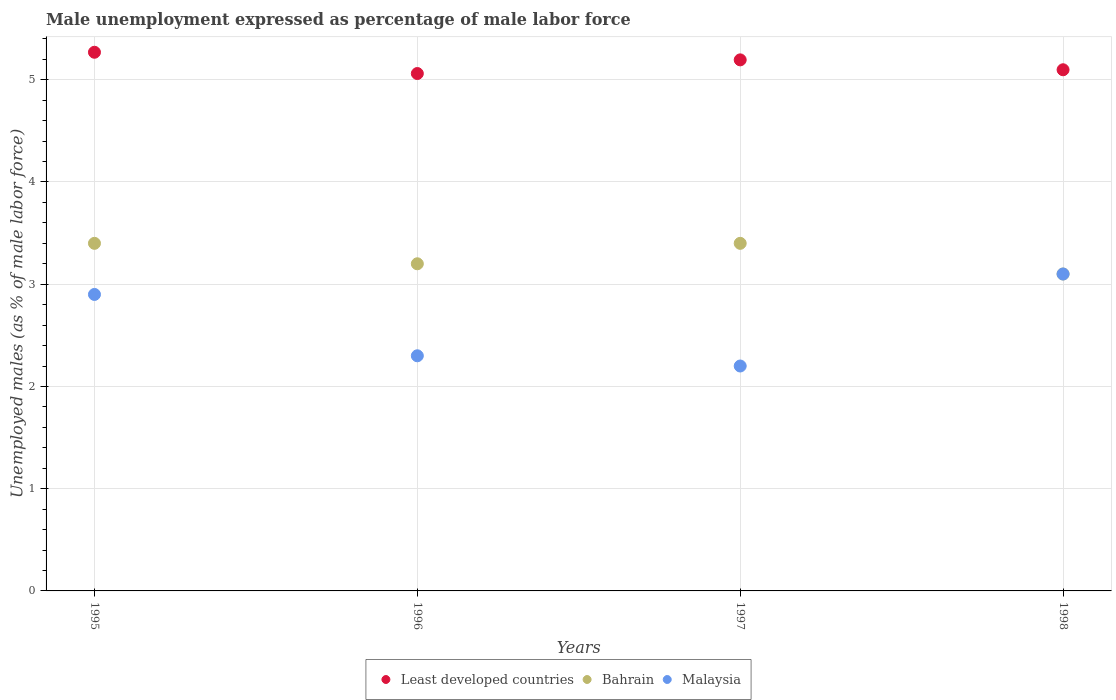How many different coloured dotlines are there?
Give a very brief answer. 3. What is the unemployment in males in in Malaysia in 1995?
Provide a succinct answer. 2.9. Across all years, what is the maximum unemployment in males in in Bahrain?
Provide a succinct answer. 3.4. Across all years, what is the minimum unemployment in males in in Bahrain?
Provide a short and direct response. 3.1. In which year was the unemployment in males in in Least developed countries minimum?
Offer a very short reply. 1996. What is the total unemployment in males in in Malaysia in the graph?
Ensure brevity in your answer.  10.5. What is the difference between the unemployment in males in in Bahrain in 1997 and that in 1998?
Provide a succinct answer. 0.3. What is the difference between the unemployment in males in in Bahrain in 1995 and the unemployment in males in in Least developed countries in 1996?
Offer a terse response. -1.66. What is the average unemployment in males in in Bahrain per year?
Make the answer very short. 3.28. In the year 1996, what is the difference between the unemployment in males in in Least developed countries and unemployment in males in in Malaysia?
Offer a very short reply. 2.76. What is the ratio of the unemployment in males in in Least developed countries in 1995 to that in 1997?
Provide a short and direct response. 1.01. Is the difference between the unemployment in males in in Least developed countries in 1995 and 1998 greater than the difference between the unemployment in males in in Malaysia in 1995 and 1998?
Provide a succinct answer. Yes. What is the difference between the highest and the lowest unemployment in males in in Least developed countries?
Your answer should be compact. 0.21. In how many years, is the unemployment in males in in Least developed countries greater than the average unemployment in males in in Least developed countries taken over all years?
Your answer should be very brief. 2. Is it the case that in every year, the sum of the unemployment in males in in Least developed countries and unemployment in males in in Bahrain  is greater than the unemployment in males in in Malaysia?
Give a very brief answer. Yes. Does the unemployment in males in in Malaysia monotonically increase over the years?
Your answer should be compact. No. Is the unemployment in males in in Malaysia strictly greater than the unemployment in males in in Least developed countries over the years?
Give a very brief answer. No. What is the difference between two consecutive major ticks on the Y-axis?
Keep it short and to the point. 1. Does the graph contain any zero values?
Keep it short and to the point. No. Does the graph contain grids?
Keep it short and to the point. Yes. Where does the legend appear in the graph?
Give a very brief answer. Bottom center. How many legend labels are there?
Provide a succinct answer. 3. How are the legend labels stacked?
Your answer should be very brief. Horizontal. What is the title of the graph?
Your answer should be compact. Male unemployment expressed as percentage of male labor force. Does "Jordan" appear as one of the legend labels in the graph?
Make the answer very short. No. What is the label or title of the X-axis?
Your response must be concise. Years. What is the label or title of the Y-axis?
Make the answer very short. Unemployed males (as % of male labor force). What is the Unemployed males (as % of male labor force) of Least developed countries in 1995?
Make the answer very short. 5.27. What is the Unemployed males (as % of male labor force) of Bahrain in 1995?
Give a very brief answer. 3.4. What is the Unemployed males (as % of male labor force) of Malaysia in 1995?
Offer a terse response. 2.9. What is the Unemployed males (as % of male labor force) of Least developed countries in 1996?
Offer a very short reply. 5.06. What is the Unemployed males (as % of male labor force) in Bahrain in 1996?
Make the answer very short. 3.2. What is the Unemployed males (as % of male labor force) of Malaysia in 1996?
Your answer should be very brief. 2.3. What is the Unemployed males (as % of male labor force) of Least developed countries in 1997?
Give a very brief answer. 5.19. What is the Unemployed males (as % of male labor force) of Bahrain in 1997?
Provide a succinct answer. 3.4. What is the Unemployed males (as % of male labor force) in Malaysia in 1997?
Provide a short and direct response. 2.2. What is the Unemployed males (as % of male labor force) of Least developed countries in 1998?
Offer a terse response. 5.1. What is the Unemployed males (as % of male labor force) in Bahrain in 1998?
Provide a short and direct response. 3.1. What is the Unemployed males (as % of male labor force) in Malaysia in 1998?
Offer a terse response. 3.1. Across all years, what is the maximum Unemployed males (as % of male labor force) in Least developed countries?
Your answer should be compact. 5.27. Across all years, what is the maximum Unemployed males (as % of male labor force) in Bahrain?
Provide a succinct answer. 3.4. Across all years, what is the maximum Unemployed males (as % of male labor force) of Malaysia?
Your answer should be compact. 3.1. Across all years, what is the minimum Unemployed males (as % of male labor force) of Least developed countries?
Offer a terse response. 5.06. Across all years, what is the minimum Unemployed males (as % of male labor force) of Bahrain?
Offer a very short reply. 3.1. Across all years, what is the minimum Unemployed males (as % of male labor force) in Malaysia?
Provide a succinct answer. 2.2. What is the total Unemployed males (as % of male labor force) of Least developed countries in the graph?
Offer a very short reply. 20.62. What is the total Unemployed males (as % of male labor force) in Bahrain in the graph?
Your answer should be very brief. 13.1. What is the total Unemployed males (as % of male labor force) of Malaysia in the graph?
Your response must be concise. 10.5. What is the difference between the Unemployed males (as % of male labor force) in Least developed countries in 1995 and that in 1996?
Your answer should be very brief. 0.21. What is the difference between the Unemployed males (as % of male labor force) of Malaysia in 1995 and that in 1996?
Offer a terse response. 0.6. What is the difference between the Unemployed males (as % of male labor force) of Least developed countries in 1995 and that in 1997?
Make the answer very short. 0.07. What is the difference between the Unemployed males (as % of male labor force) in Malaysia in 1995 and that in 1997?
Your response must be concise. 0.7. What is the difference between the Unemployed males (as % of male labor force) in Least developed countries in 1995 and that in 1998?
Offer a very short reply. 0.17. What is the difference between the Unemployed males (as % of male labor force) in Bahrain in 1995 and that in 1998?
Your answer should be very brief. 0.3. What is the difference between the Unemployed males (as % of male labor force) in Malaysia in 1995 and that in 1998?
Provide a short and direct response. -0.2. What is the difference between the Unemployed males (as % of male labor force) in Least developed countries in 1996 and that in 1997?
Provide a succinct answer. -0.13. What is the difference between the Unemployed males (as % of male labor force) of Bahrain in 1996 and that in 1997?
Your response must be concise. -0.2. What is the difference between the Unemployed males (as % of male labor force) of Malaysia in 1996 and that in 1997?
Your response must be concise. 0.1. What is the difference between the Unemployed males (as % of male labor force) in Least developed countries in 1996 and that in 1998?
Keep it short and to the point. -0.04. What is the difference between the Unemployed males (as % of male labor force) of Least developed countries in 1997 and that in 1998?
Offer a terse response. 0.1. What is the difference between the Unemployed males (as % of male labor force) in Bahrain in 1997 and that in 1998?
Your answer should be compact. 0.3. What is the difference between the Unemployed males (as % of male labor force) of Least developed countries in 1995 and the Unemployed males (as % of male labor force) of Bahrain in 1996?
Give a very brief answer. 2.07. What is the difference between the Unemployed males (as % of male labor force) of Least developed countries in 1995 and the Unemployed males (as % of male labor force) of Malaysia in 1996?
Give a very brief answer. 2.97. What is the difference between the Unemployed males (as % of male labor force) of Least developed countries in 1995 and the Unemployed males (as % of male labor force) of Bahrain in 1997?
Your response must be concise. 1.87. What is the difference between the Unemployed males (as % of male labor force) of Least developed countries in 1995 and the Unemployed males (as % of male labor force) of Malaysia in 1997?
Offer a terse response. 3.07. What is the difference between the Unemployed males (as % of male labor force) in Least developed countries in 1995 and the Unemployed males (as % of male labor force) in Bahrain in 1998?
Keep it short and to the point. 2.17. What is the difference between the Unemployed males (as % of male labor force) of Least developed countries in 1995 and the Unemployed males (as % of male labor force) of Malaysia in 1998?
Make the answer very short. 2.17. What is the difference between the Unemployed males (as % of male labor force) in Least developed countries in 1996 and the Unemployed males (as % of male labor force) in Bahrain in 1997?
Keep it short and to the point. 1.66. What is the difference between the Unemployed males (as % of male labor force) of Least developed countries in 1996 and the Unemployed males (as % of male labor force) of Malaysia in 1997?
Your response must be concise. 2.86. What is the difference between the Unemployed males (as % of male labor force) of Least developed countries in 1996 and the Unemployed males (as % of male labor force) of Bahrain in 1998?
Provide a short and direct response. 1.96. What is the difference between the Unemployed males (as % of male labor force) of Least developed countries in 1996 and the Unemployed males (as % of male labor force) of Malaysia in 1998?
Make the answer very short. 1.96. What is the difference between the Unemployed males (as % of male labor force) in Least developed countries in 1997 and the Unemployed males (as % of male labor force) in Bahrain in 1998?
Your response must be concise. 2.09. What is the difference between the Unemployed males (as % of male labor force) of Least developed countries in 1997 and the Unemployed males (as % of male labor force) of Malaysia in 1998?
Offer a very short reply. 2.09. What is the average Unemployed males (as % of male labor force) of Least developed countries per year?
Your answer should be compact. 5.16. What is the average Unemployed males (as % of male labor force) of Bahrain per year?
Provide a succinct answer. 3.27. What is the average Unemployed males (as % of male labor force) of Malaysia per year?
Offer a terse response. 2.62. In the year 1995, what is the difference between the Unemployed males (as % of male labor force) of Least developed countries and Unemployed males (as % of male labor force) of Bahrain?
Provide a succinct answer. 1.87. In the year 1995, what is the difference between the Unemployed males (as % of male labor force) in Least developed countries and Unemployed males (as % of male labor force) in Malaysia?
Offer a very short reply. 2.37. In the year 1995, what is the difference between the Unemployed males (as % of male labor force) in Bahrain and Unemployed males (as % of male labor force) in Malaysia?
Keep it short and to the point. 0.5. In the year 1996, what is the difference between the Unemployed males (as % of male labor force) in Least developed countries and Unemployed males (as % of male labor force) in Bahrain?
Offer a very short reply. 1.86. In the year 1996, what is the difference between the Unemployed males (as % of male labor force) of Least developed countries and Unemployed males (as % of male labor force) of Malaysia?
Provide a short and direct response. 2.76. In the year 1996, what is the difference between the Unemployed males (as % of male labor force) of Bahrain and Unemployed males (as % of male labor force) of Malaysia?
Offer a terse response. 0.9. In the year 1997, what is the difference between the Unemployed males (as % of male labor force) of Least developed countries and Unemployed males (as % of male labor force) of Bahrain?
Give a very brief answer. 1.79. In the year 1997, what is the difference between the Unemployed males (as % of male labor force) of Least developed countries and Unemployed males (as % of male labor force) of Malaysia?
Provide a succinct answer. 2.99. In the year 1997, what is the difference between the Unemployed males (as % of male labor force) of Bahrain and Unemployed males (as % of male labor force) of Malaysia?
Give a very brief answer. 1.2. In the year 1998, what is the difference between the Unemployed males (as % of male labor force) in Least developed countries and Unemployed males (as % of male labor force) in Bahrain?
Your answer should be very brief. 2. In the year 1998, what is the difference between the Unemployed males (as % of male labor force) in Least developed countries and Unemployed males (as % of male labor force) in Malaysia?
Offer a terse response. 2. In the year 1998, what is the difference between the Unemployed males (as % of male labor force) of Bahrain and Unemployed males (as % of male labor force) of Malaysia?
Ensure brevity in your answer.  0. What is the ratio of the Unemployed males (as % of male labor force) of Least developed countries in 1995 to that in 1996?
Your response must be concise. 1.04. What is the ratio of the Unemployed males (as % of male labor force) in Malaysia in 1995 to that in 1996?
Your response must be concise. 1.26. What is the ratio of the Unemployed males (as % of male labor force) in Least developed countries in 1995 to that in 1997?
Make the answer very short. 1.01. What is the ratio of the Unemployed males (as % of male labor force) in Malaysia in 1995 to that in 1997?
Ensure brevity in your answer.  1.32. What is the ratio of the Unemployed males (as % of male labor force) of Least developed countries in 1995 to that in 1998?
Your response must be concise. 1.03. What is the ratio of the Unemployed males (as % of male labor force) in Bahrain in 1995 to that in 1998?
Ensure brevity in your answer.  1.1. What is the ratio of the Unemployed males (as % of male labor force) of Malaysia in 1995 to that in 1998?
Your response must be concise. 0.94. What is the ratio of the Unemployed males (as % of male labor force) of Least developed countries in 1996 to that in 1997?
Ensure brevity in your answer.  0.97. What is the ratio of the Unemployed males (as % of male labor force) in Malaysia in 1996 to that in 1997?
Offer a very short reply. 1.05. What is the ratio of the Unemployed males (as % of male labor force) in Least developed countries in 1996 to that in 1998?
Offer a terse response. 0.99. What is the ratio of the Unemployed males (as % of male labor force) of Bahrain in 1996 to that in 1998?
Offer a terse response. 1.03. What is the ratio of the Unemployed males (as % of male labor force) of Malaysia in 1996 to that in 1998?
Provide a short and direct response. 0.74. What is the ratio of the Unemployed males (as % of male labor force) of Bahrain in 1997 to that in 1998?
Ensure brevity in your answer.  1.1. What is the ratio of the Unemployed males (as % of male labor force) in Malaysia in 1997 to that in 1998?
Your answer should be very brief. 0.71. What is the difference between the highest and the second highest Unemployed males (as % of male labor force) in Least developed countries?
Your response must be concise. 0.07. What is the difference between the highest and the lowest Unemployed males (as % of male labor force) of Least developed countries?
Make the answer very short. 0.21. What is the difference between the highest and the lowest Unemployed males (as % of male labor force) of Bahrain?
Give a very brief answer. 0.3. 